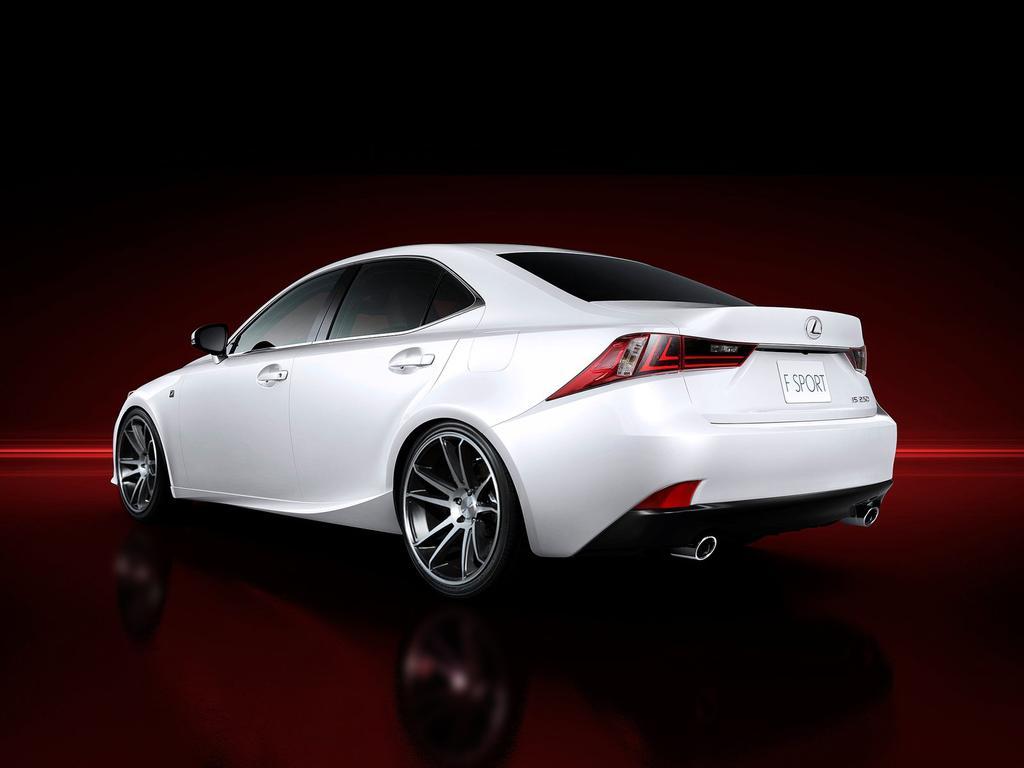Describe this image in one or two sentences. In this image there is a white car in the background it is dark and red. 